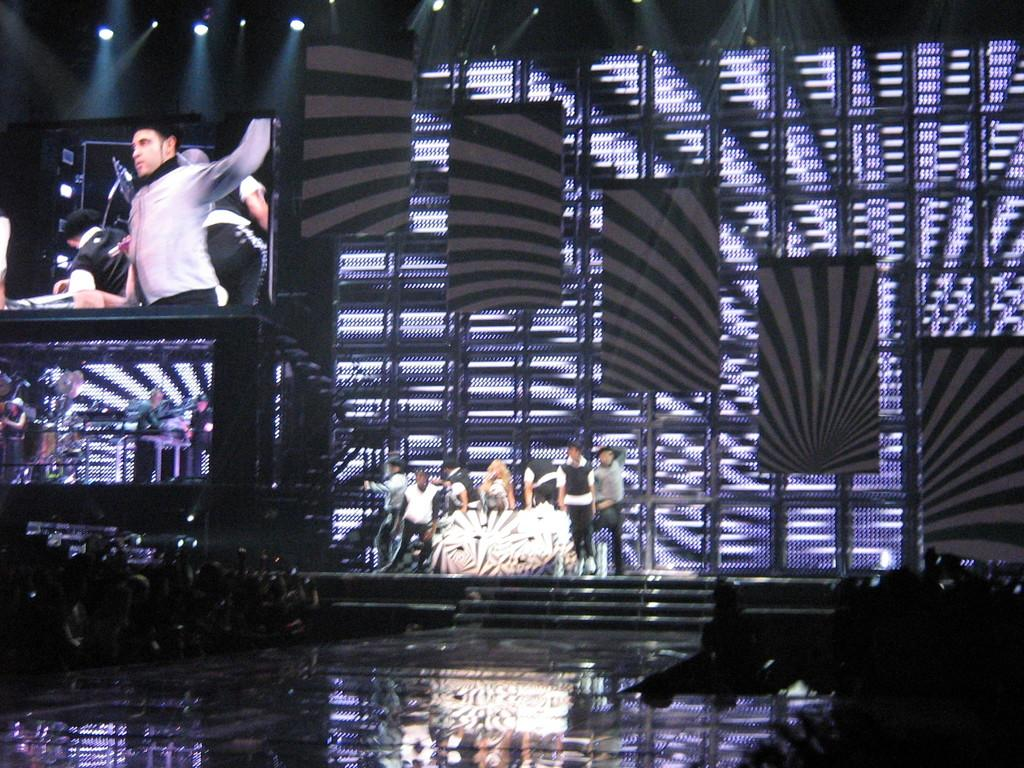What is happening in the center of the image? There are persons performing on a dais in the center of the image. What can be seen at the bottom of the image? There are persons and daisy at the bottom of the image. What is visible in the background of the image? There are screens and lights in the background of the image. What type of cover is protecting the daisy from the winter in the image? There is no mention of winter or a cover in the image; it features a performance on a dais and a daisy at the bottom. Can you solve the riddle that is being presented by the performers in the image? There is no riddle mentioned in the image; it only shows a performance on a dais and other elements. 